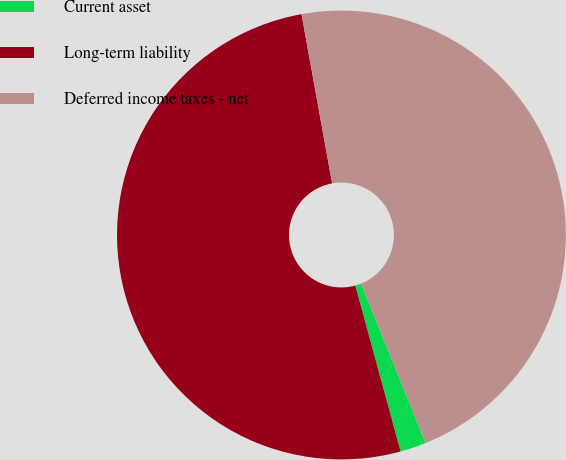Convert chart to OTSL. <chart><loc_0><loc_0><loc_500><loc_500><pie_chart><fcel>Current asset<fcel>Long-term liability<fcel>Deferred income taxes - net<nl><fcel>1.88%<fcel>51.39%<fcel>46.72%<nl></chart> 